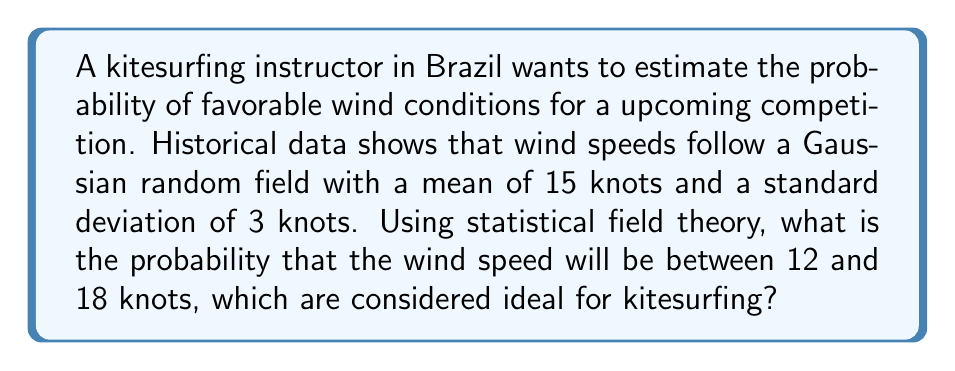Could you help me with this problem? To solve this problem, we'll use concepts from statistical field theory and the properties of Gaussian distributions:

1) The wind speed follows a Gaussian (normal) distribution with:
   Mean (μ) = 15 knots
   Standard deviation (σ) = 3 knots

2) We need to find the probability that the wind speed (X) is between 12 and 18 knots:
   P(12 ≤ X ≤ 18)

3) Standardize the random variable:
   For the lower bound: z₁ = (12 - 15) / 3 = -1
   For the upper bound: z₂ = (18 - 15) / 3 = 1

4) The probability is now:
   P(-1 ≤ Z ≤ 1), where Z is the standard normal variable

5) Use the standard normal cumulative distribution function Φ(z):
   P(-1 ≤ Z ≤ 1) = Φ(1) - Φ(-1)

6) From the standard normal table or calculator:
   Φ(1) ≈ 0.8413
   Φ(-1) = 1 - Φ(1) ≈ 0.1587

7) Therefore:
   P(12 ≤ X ≤ 18) = Φ(1) - Φ(-1) ≈ 0.8413 - 0.1587 = 0.6826

8) Convert to percentage:
   0.6826 * 100% ≈ 68.26%
Answer: 68.26% 